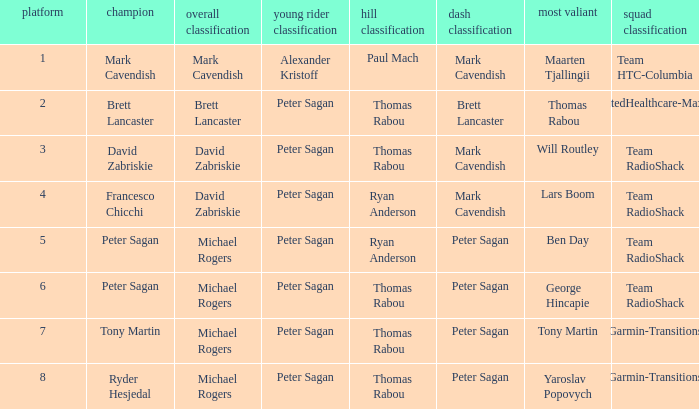When Ryan Anderson won the mountains classification, and Michael Rogers won the general classification, who won the sprint classification? Peter Sagan. 